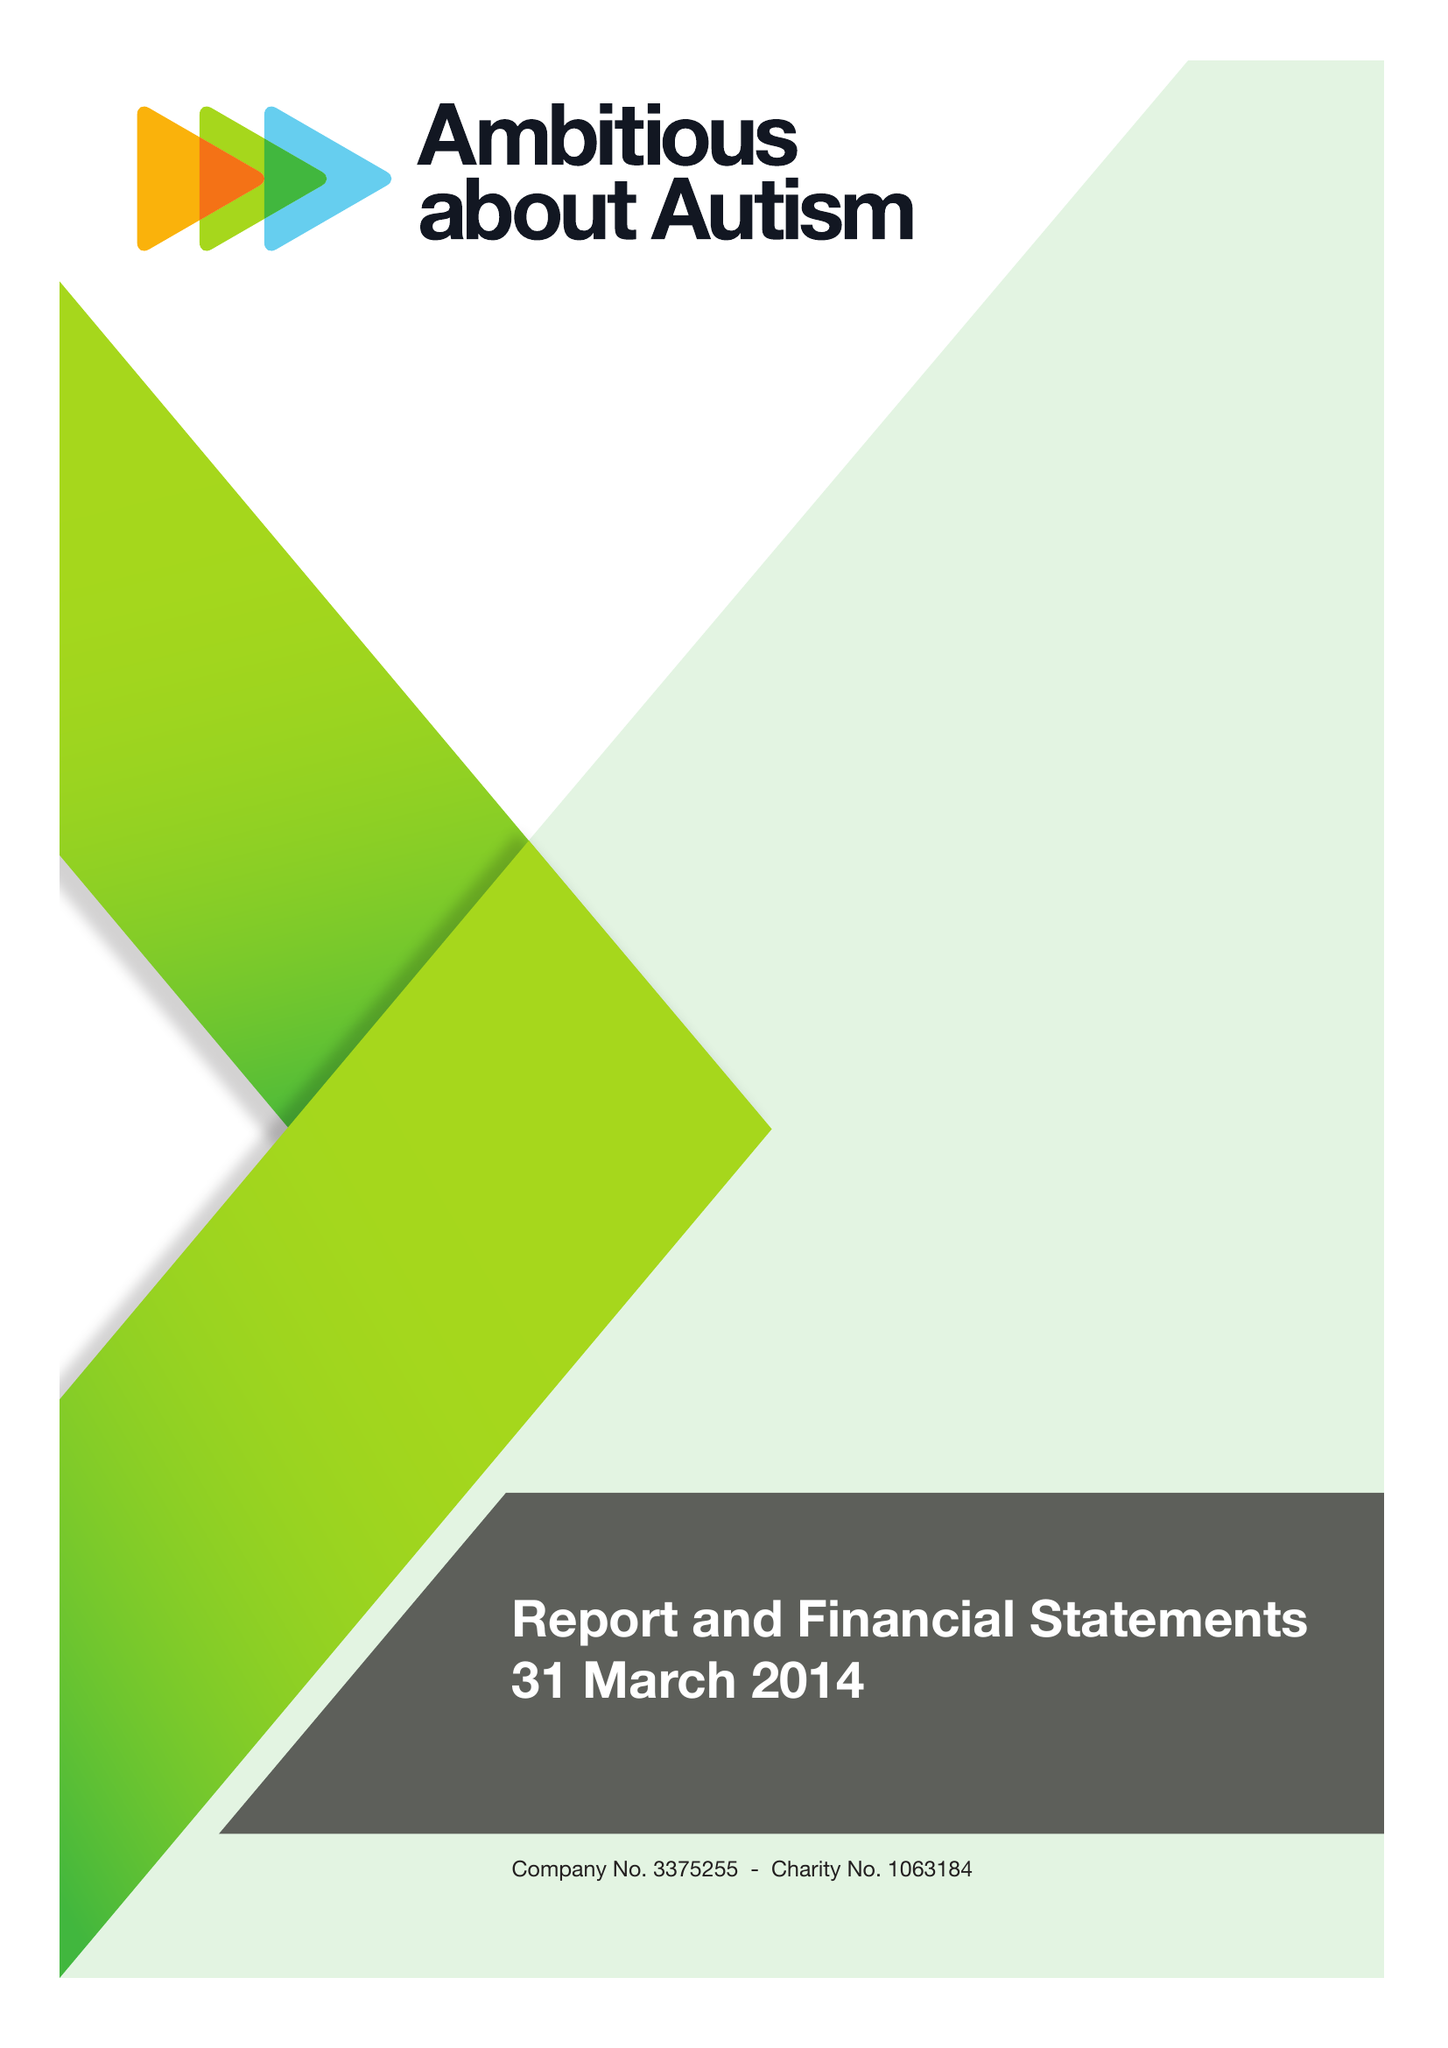What is the value for the report_date?
Answer the question using a single word or phrase. 2014-03-31 